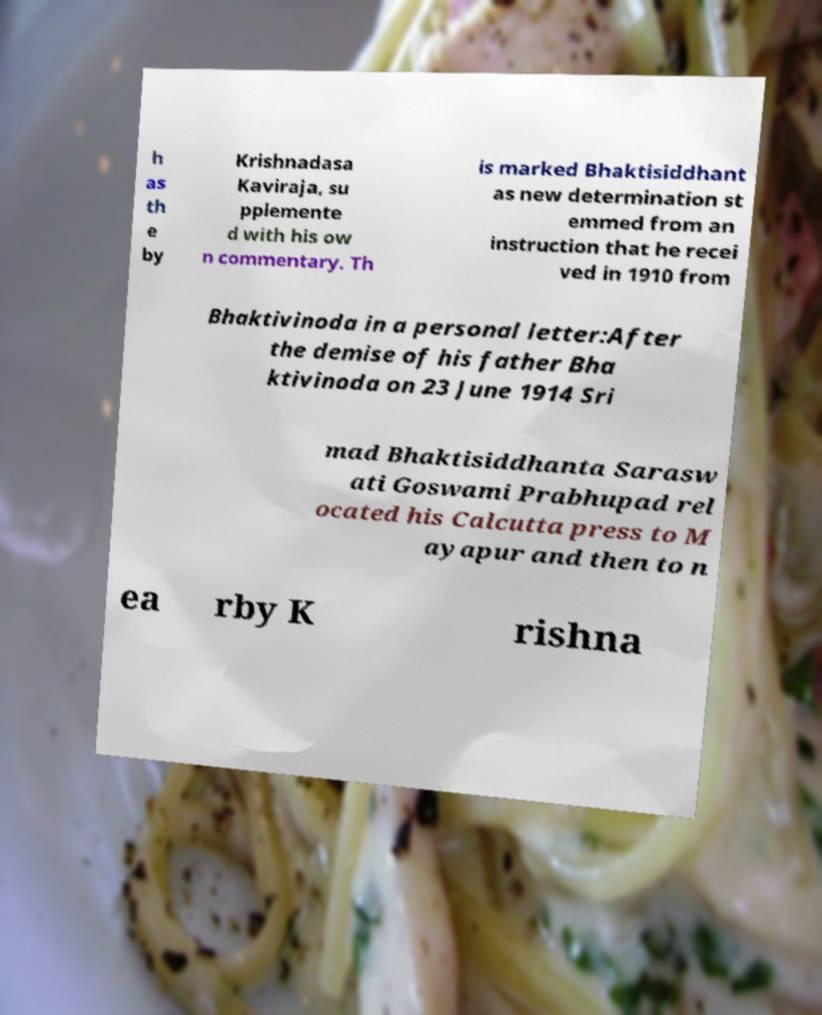I need the written content from this picture converted into text. Can you do that? h as th e by Krishnadasa Kaviraja, su pplemente d with his ow n commentary. Th is marked Bhaktisiddhant as new determination st emmed from an instruction that he recei ved in 1910 from Bhaktivinoda in a personal letter:After the demise of his father Bha ktivinoda on 23 June 1914 Sri mad Bhaktisiddhanta Sarasw ati Goswami Prabhupad rel ocated his Calcutta press to M ayapur and then to n ea rby K rishna 